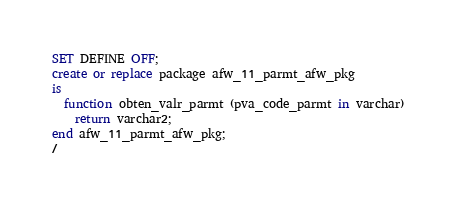Convert code to text. <code><loc_0><loc_0><loc_500><loc_500><_SQL_>SET DEFINE OFF;
create or replace package afw_11_parmt_afw_pkg
is
  function obten_valr_parmt (pva_code_parmt in varchar)
    return varchar2;
end afw_11_parmt_afw_pkg;
/
</code> 